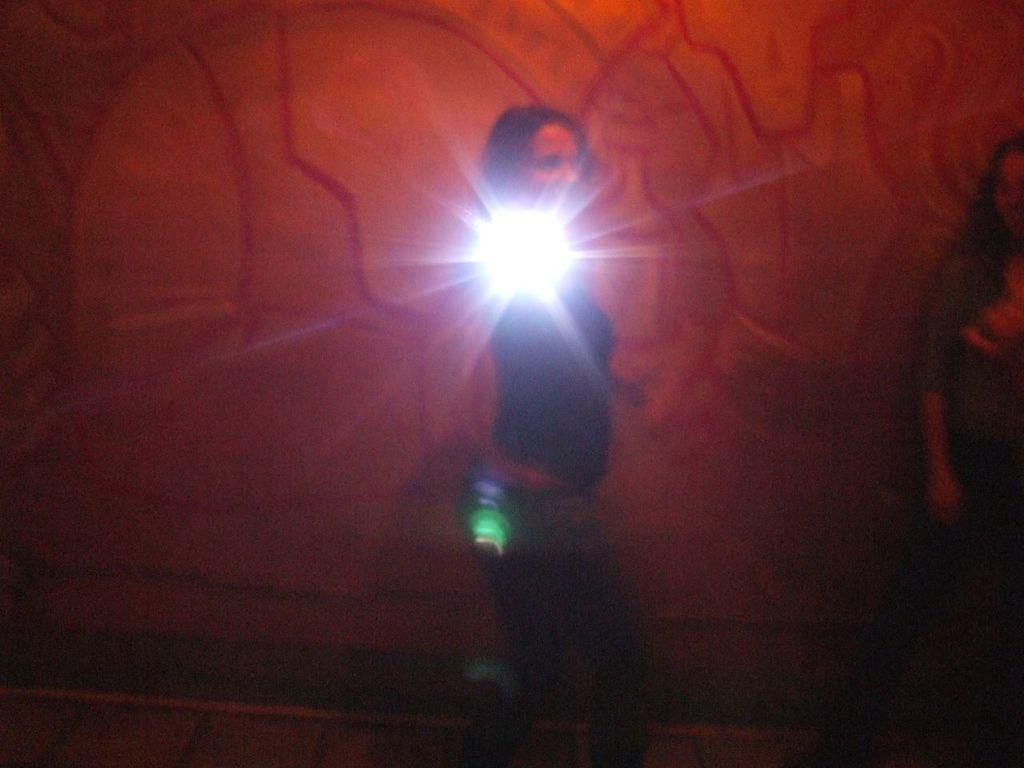How would you summarize this image in a sentence or two? In this picture we can see a person and lights. We can see another person on the right side. It looks like a colorful wall in the background. 